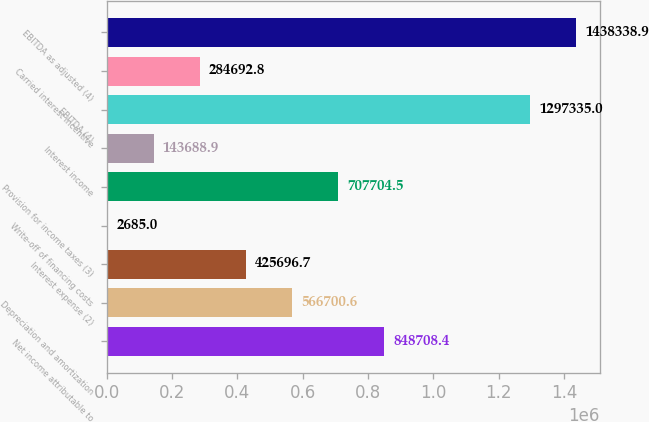Convert chart. <chart><loc_0><loc_0><loc_500><loc_500><bar_chart><fcel>Net income attributable to<fcel>Depreciation and amortization<fcel>Interest expense (2)<fcel>Write-off of financing costs<fcel>Provision for income taxes (3)<fcel>Interest income<fcel>EBITDA (4)<fcel>Carried interest incentive<fcel>EBITDA as adjusted (4)<nl><fcel>848708<fcel>566701<fcel>425697<fcel>2685<fcel>707704<fcel>143689<fcel>1.29734e+06<fcel>284693<fcel>1.43834e+06<nl></chart> 